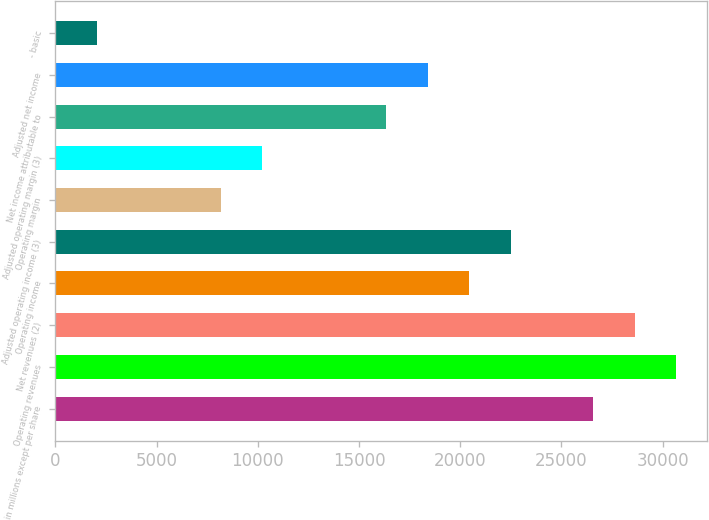Convert chart to OTSL. <chart><loc_0><loc_0><loc_500><loc_500><bar_chart><fcel>in millions except per share<fcel>Operating revenues<fcel>Net revenues (2)<fcel>Operating income<fcel>Adjusted operating income (3)<fcel>Operating margin<fcel>Adjusted operating margin (3)<fcel>Net income attributable to<fcel>Adjusted net income<fcel>- basic<nl><fcel>26584.7<fcel>30674.5<fcel>28629.6<fcel>20450<fcel>22494.9<fcel>8180.57<fcel>10225.5<fcel>16360.2<fcel>18405.1<fcel>2045.87<nl></chart> 